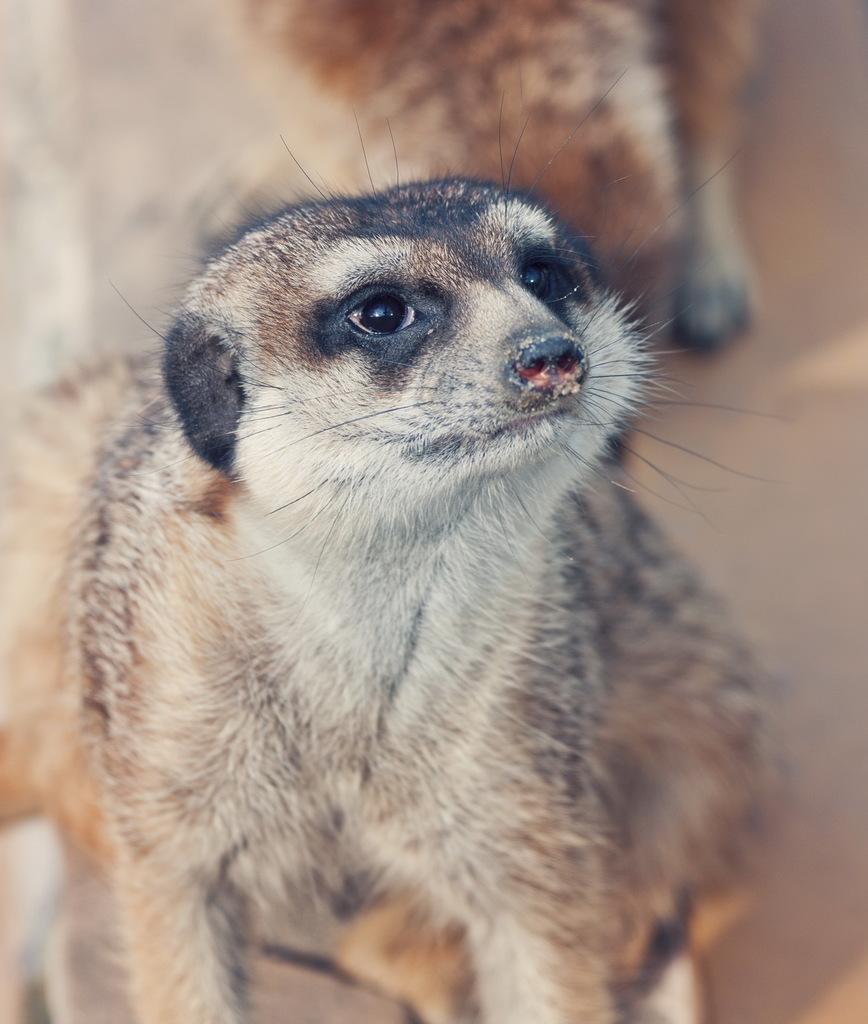Could you give a brief overview of what you see in this image? There is a meerkat. The background is blurred. 